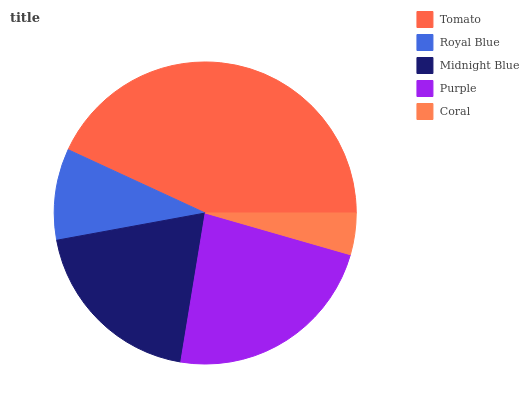Is Coral the minimum?
Answer yes or no. Yes. Is Tomato the maximum?
Answer yes or no. Yes. Is Royal Blue the minimum?
Answer yes or no. No. Is Royal Blue the maximum?
Answer yes or no. No. Is Tomato greater than Royal Blue?
Answer yes or no. Yes. Is Royal Blue less than Tomato?
Answer yes or no. Yes. Is Royal Blue greater than Tomato?
Answer yes or no. No. Is Tomato less than Royal Blue?
Answer yes or no. No. Is Midnight Blue the high median?
Answer yes or no. Yes. Is Midnight Blue the low median?
Answer yes or no. Yes. Is Tomato the high median?
Answer yes or no. No. Is Coral the low median?
Answer yes or no. No. 